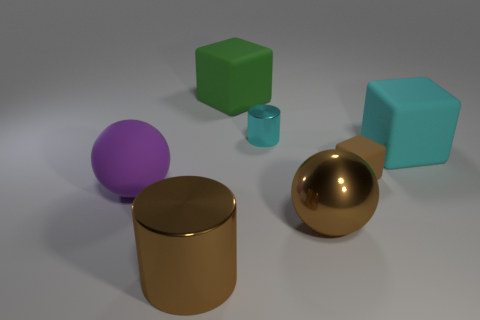How big is the rubber object that is to the left of the brown cylinder?
Offer a very short reply. Large. What is the shape of the purple object that is the same material as the big cyan block?
Provide a succinct answer. Sphere. Is the material of the big sphere that is right of the big metallic cylinder the same as the big brown cylinder?
Make the answer very short. Yes. How many other things are made of the same material as the brown ball?
Offer a terse response. 2. What number of objects are cyan objects to the right of the tiny cyan metal thing or large blocks to the right of the brown metallic sphere?
Ensure brevity in your answer.  1. Do the large rubber object in front of the tiny brown matte thing and the large brown thing left of the big brown ball have the same shape?
Keep it short and to the point. No. What is the shape of the green thing that is the same size as the purple ball?
Ensure brevity in your answer.  Cube. How many rubber things are big red cylinders or big green things?
Your response must be concise. 1. Is the cyan object in front of the tiny cyan thing made of the same material as the big block left of the tiny rubber object?
Provide a succinct answer. Yes. There is a small thing that is the same material as the big brown ball; what color is it?
Offer a terse response. Cyan. 